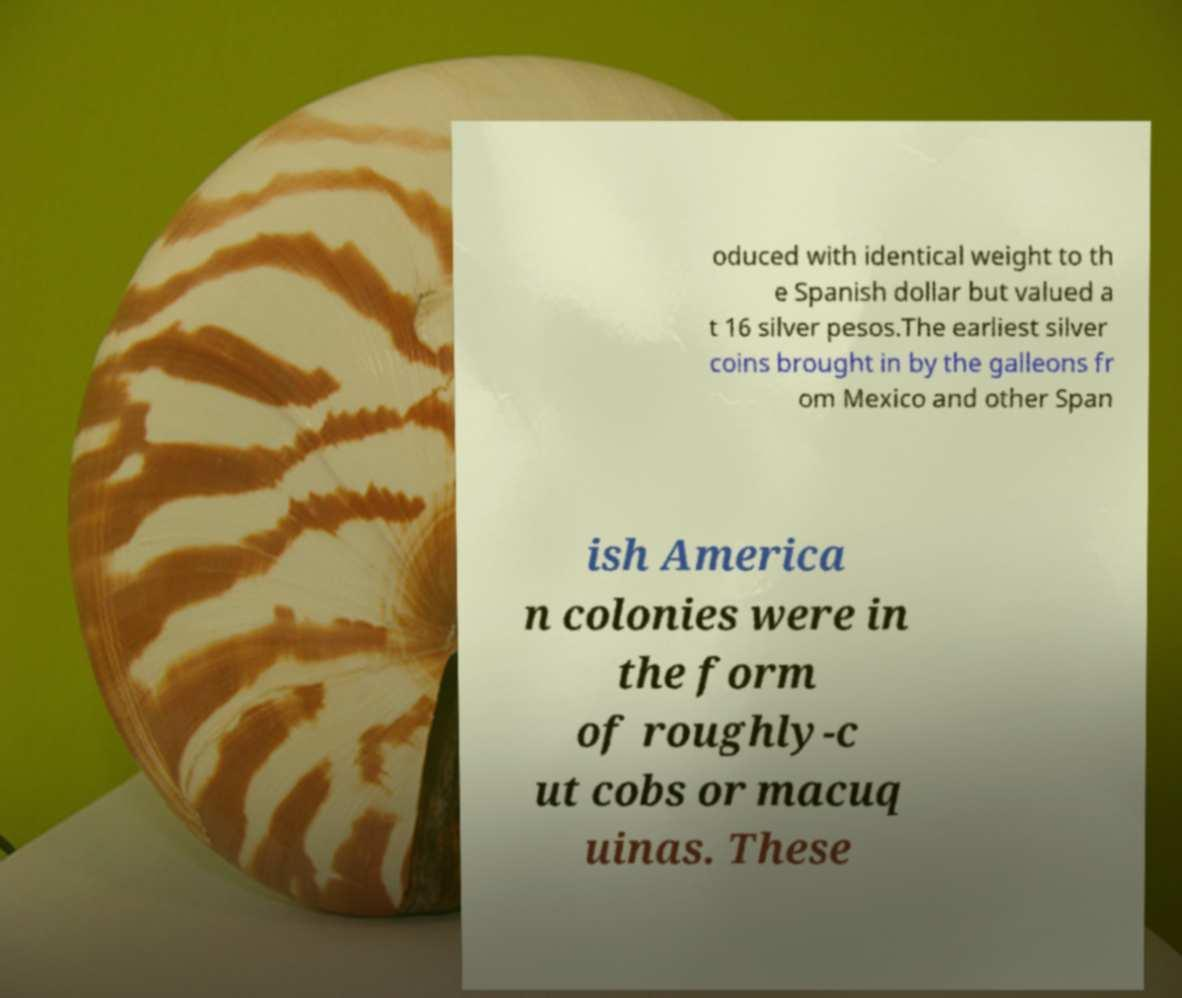Can you read and provide the text displayed in the image?This photo seems to have some interesting text. Can you extract and type it out for me? oduced with identical weight to th e Spanish dollar but valued a t 16 silver pesos.The earliest silver coins brought in by the galleons fr om Mexico and other Span ish America n colonies were in the form of roughly-c ut cobs or macuq uinas. These 